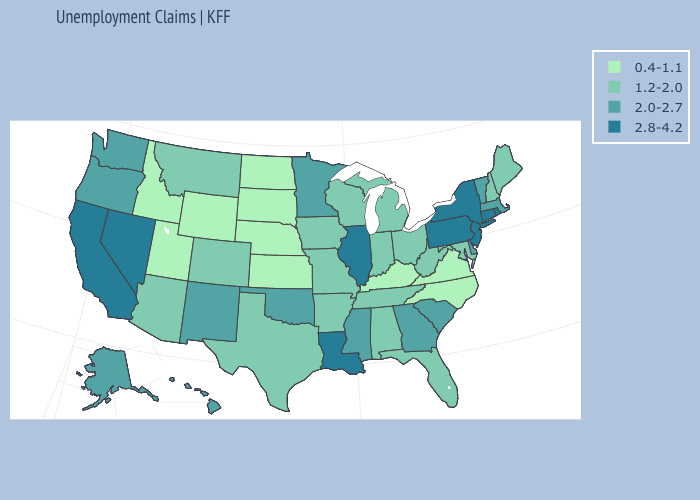Does the first symbol in the legend represent the smallest category?
Give a very brief answer. Yes. What is the value of Oregon?
Quick response, please. 2.0-2.7. Does the map have missing data?
Give a very brief answer. No. What is the value of Texas?
Concise answer only. 1.2-2.0. What is the value of Illinois?
Quick response, please. 2.8-4.2. Which states have the highest value in the USA?
Give a very brief answer. California, Connecticut, Illinois, Louisiana, Nevada, New Jersey, New York, Pennsylvania, Rhode Island. Name the states that have a value in the range 1.2-2.0?
Be succinct. Alabama, Arizona, Arkansas, Colorado, Florida, Indiana, Iowa, Maine, Maryland, Michigan, Missouri, Montana, New Hampshire, Ohio, Tennessee, Texas, West Virginia, Wisconsin. Which states have the highest value in the USA?
Give a very brief answer. California, Connecticut, Illinois, Louisiana, Nevada, New Jersey, New York, Pennsylvania, Rhode Island. Which states have the lowest value in the MidWest?
Keep it brief. Kansas, Nebraska, North Dakota, South Dakota. Which states have the highest value in the USA?
Be succinct. California, Connecticut, Illinois, Louisiana, Nevada, New Jersey, New York, Pennsylvania, Rhode Island. What is the value of Delaware?
Answer briefly. 2.0-2.7. What is the value of Florida?
Concise answer only. 1.2-2.0. Does Wyoming have the lowest value in the West?
Write a very short answer. Yes. What is the value of Rhode Island?
Keep it brief. 2.8-4.2. Name the states that have a value in the range 1.2-2.0?
Quick response, please. Alabama, Arizona, Arkansas, Colorado, Florida, Indiana, Iowa, Maine, Maryland, Michigan, Missouri, Montana, New Hampshire, Ohio, Tennessee, Texas, West Virginia, Wisconsin. 